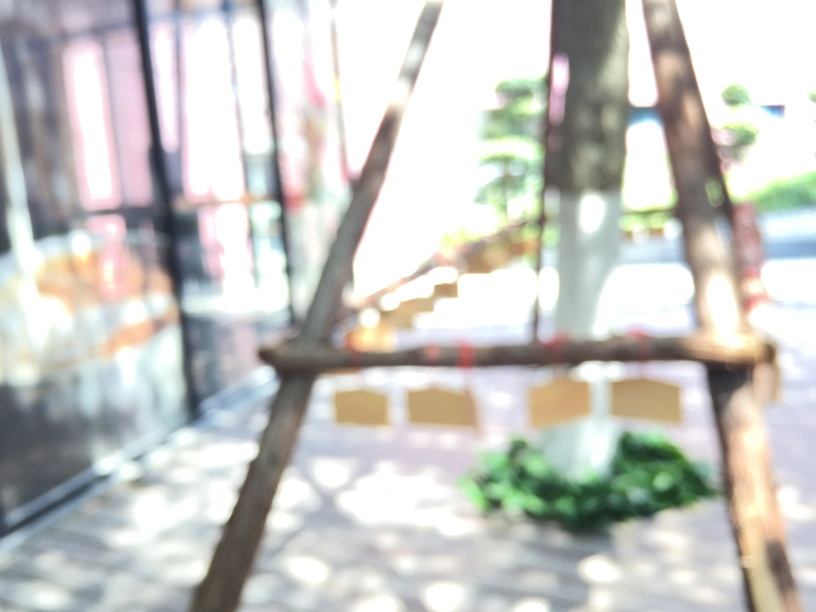If you had to guess, what might have caused the blur in this photo? The blur could be caused by a few different factors: the camera might have been moving during the shot, the subject could have been moving, or it might be a focus issue where the camera failed to lock onto a stationary object. What could be the potential subjects in this image if it were in focus? If in focus, the image might reveal an urban park setting with benches or a patio, some planters and vegetation, and perhaps people present at a distance or objects like outdoor artworks. 